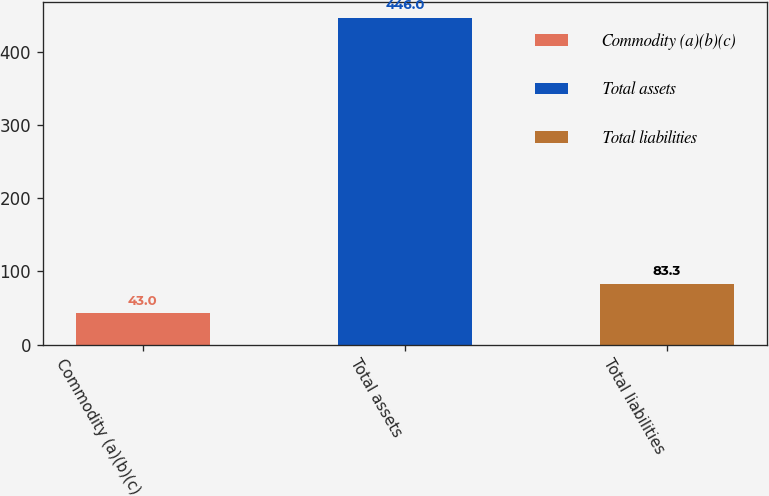Convert chart to OTSL. <chart><loc_0><loc_0><loc_500><loc_500><bar_chart><fcel>Commodity (a)(b)(c)<fcel>Total assets<fcel>Total liabilities<nl><fcel>43<fcel>446<fcel>83.3<nl></chart> 